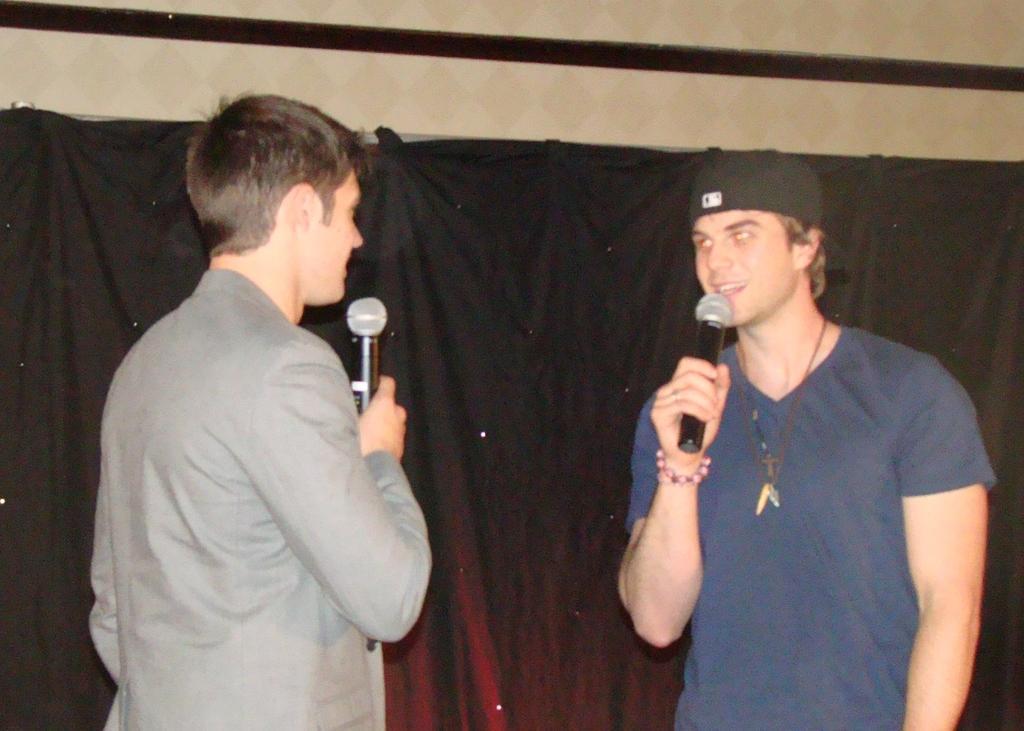How would you summarize this image in a sentence or two? In the picture we can find two men are standing and talking in the microphone to each other. In the background we can find a curtain on the wall and one man is wearing a T-shirt it is in blue in color with cap and one man is wearing a shirt. 